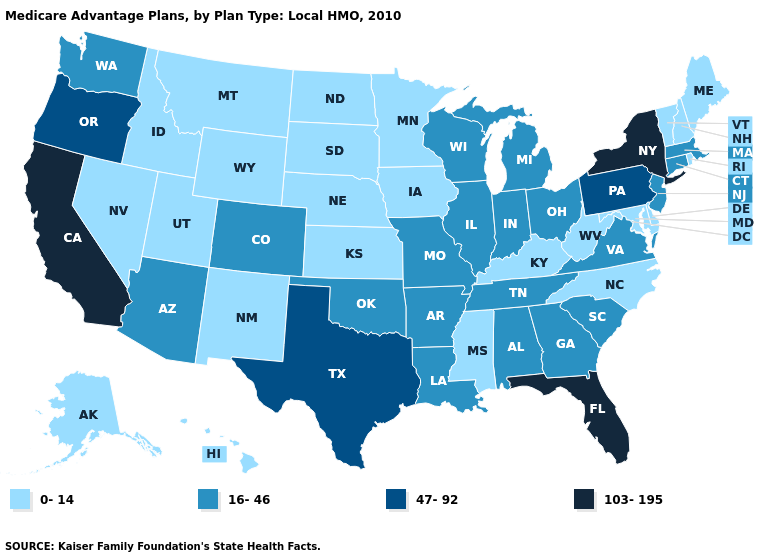Name the states that have a value in the range 103-195?
Short answer required. California, Florida, New York. Among the states that border Minnesota , does Wisconsin have the highest value?
Write a very short answer. Yes. What is the highest value in the USA?
Quick response, please. 103-195. Does Florida have the lowest value in the USA?
Concise answer only. No. Does the first symbol in the legend represent the smallest category?
Answer briefly. Yes. Name the states that have a value in the range 0-14?
Keep it brief. Alaska, Delaware, Hawaii, Iowa, Idaho, Kansas, Kentucky, Maryland, Maine, Minnesota, Mississippi, Montana, North Carolina, North Dakota, Nebraska, New Hampshire, New Mexico, Nevada, Rhode Island, South Dakota, Utah, Vermont, West Virginia, Wyoming. Does Indiana have the lowest value in the MidWest?
Give a very brief answer. No. Does Kentucky have the highest value in the USA?
Keep it brief. No. Name the states that have a value in the range 103-195?
Be succinct. California, Florida, New York. What is the value of Iowa?
Quick response, please. 0-14. Name the states that have a value in the range 47-92?
Concise answer only. Oregon, Pennsylvania, Texas. What is the lowest value in the USA?
Be succinct. 0-14. Is the legend a continuous bar?
Give a very brief answer. No. Name the states that have a value in the range 16-46?
Concise answer only. Alabama, Arkansas, Arizona, Colorado, Connecticut, Georgia, Illinois, Indiana, Louisiana, Massachusetts, Michigan, Missouri, New Jersey, Ohio, Oklahoma, South Carolina, Tennessee, Virginia, Washington, Wisconsin. What is the highest value in the West ?
Give a very brief answer. 103-195. 